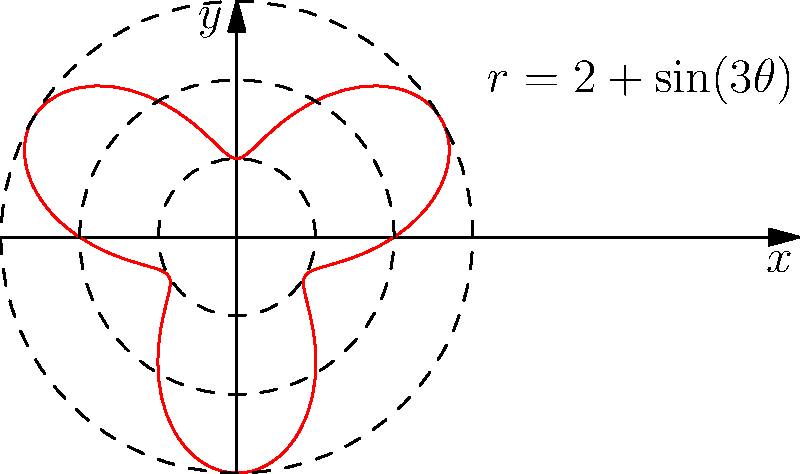The circular stained glass window in our church's new wing is designed with an intricate pattern that can be described by the polar equation $r = 2 + \sin(3\theta)$. What is the maximum radius of this window? To find the maximum radius of the window, we need to follow these steps:

1) The given equation is $r = 2 + \sin(3\theta)$.

2) The maximum value will occur when $\sin(3\theta)$ is at its maximum, which is 1.

3) Therefore, the maximum radius is:

   $$r_{max} = 2 + \sin(3\theta)_{max} = 2 + 1 = 3$$

4) This means that the window extends to a maximum of 3 units from the center at certain points.

5) We can verify this by looking at the graph, where we see that the curve touches, but does not exceed, the dashed circle with radius 3.
Answer: 3 units 